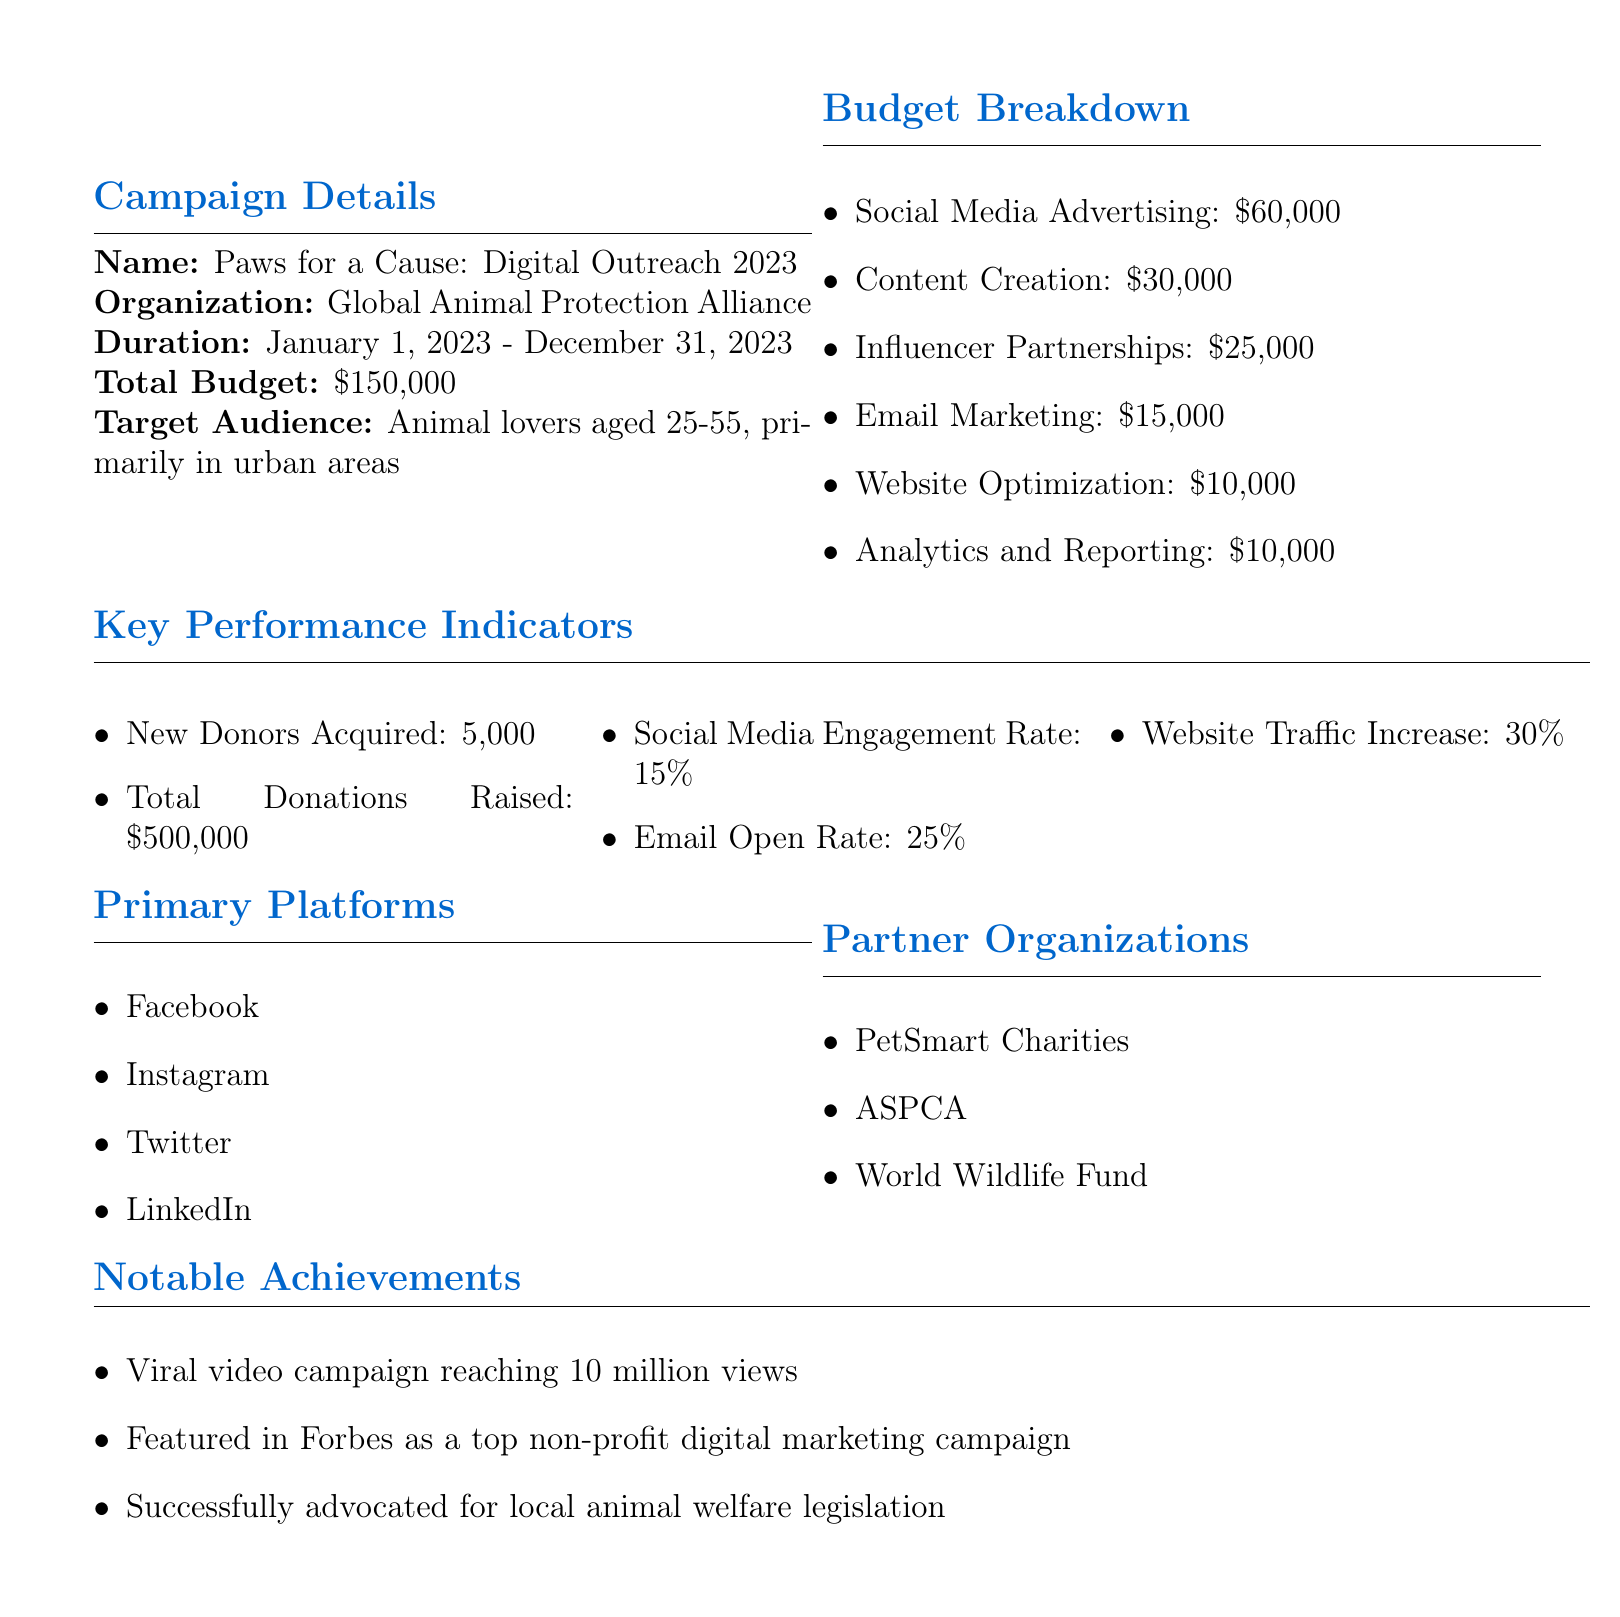What is the name of the campaign? The name of the campaign is mentioned at the beginning of the document.
Answer: Paws for a Cause: Digital Outreach 2023 What is the total budget allocated for the campaign? The total budget can be found in the campaign details section.
Answer: $150,000 How many new donors are targeted to be acquired? The number of new donors is specified in the key performance indicators section.
Answer: 5000 Which platform has the highest budget allocation? The budget breakdown details the allocation, indicating which area has the highest budget.
Answer: Social Media Advertising What is the campaign duration? The duration of the campaign is explicitly stated in the document.
Answer: January 1, 2023 - December 31, 2023 What is the email open rate target? The email open rate is listed under key performance indicators.
Answer: 25% Which organization is one of the partner organizations? Partner organizations are listed, and one can be found directly in the document.
Answer: PetSmart Charities How much budget is allocated for content creation? The budget breakdown provides exact figures for content creation.
Answer: $30,000 What notable achievement involves views? The notable achievements include various successes, one of which mentions views.
Answer: Viral video campaign reaching 10 million views 